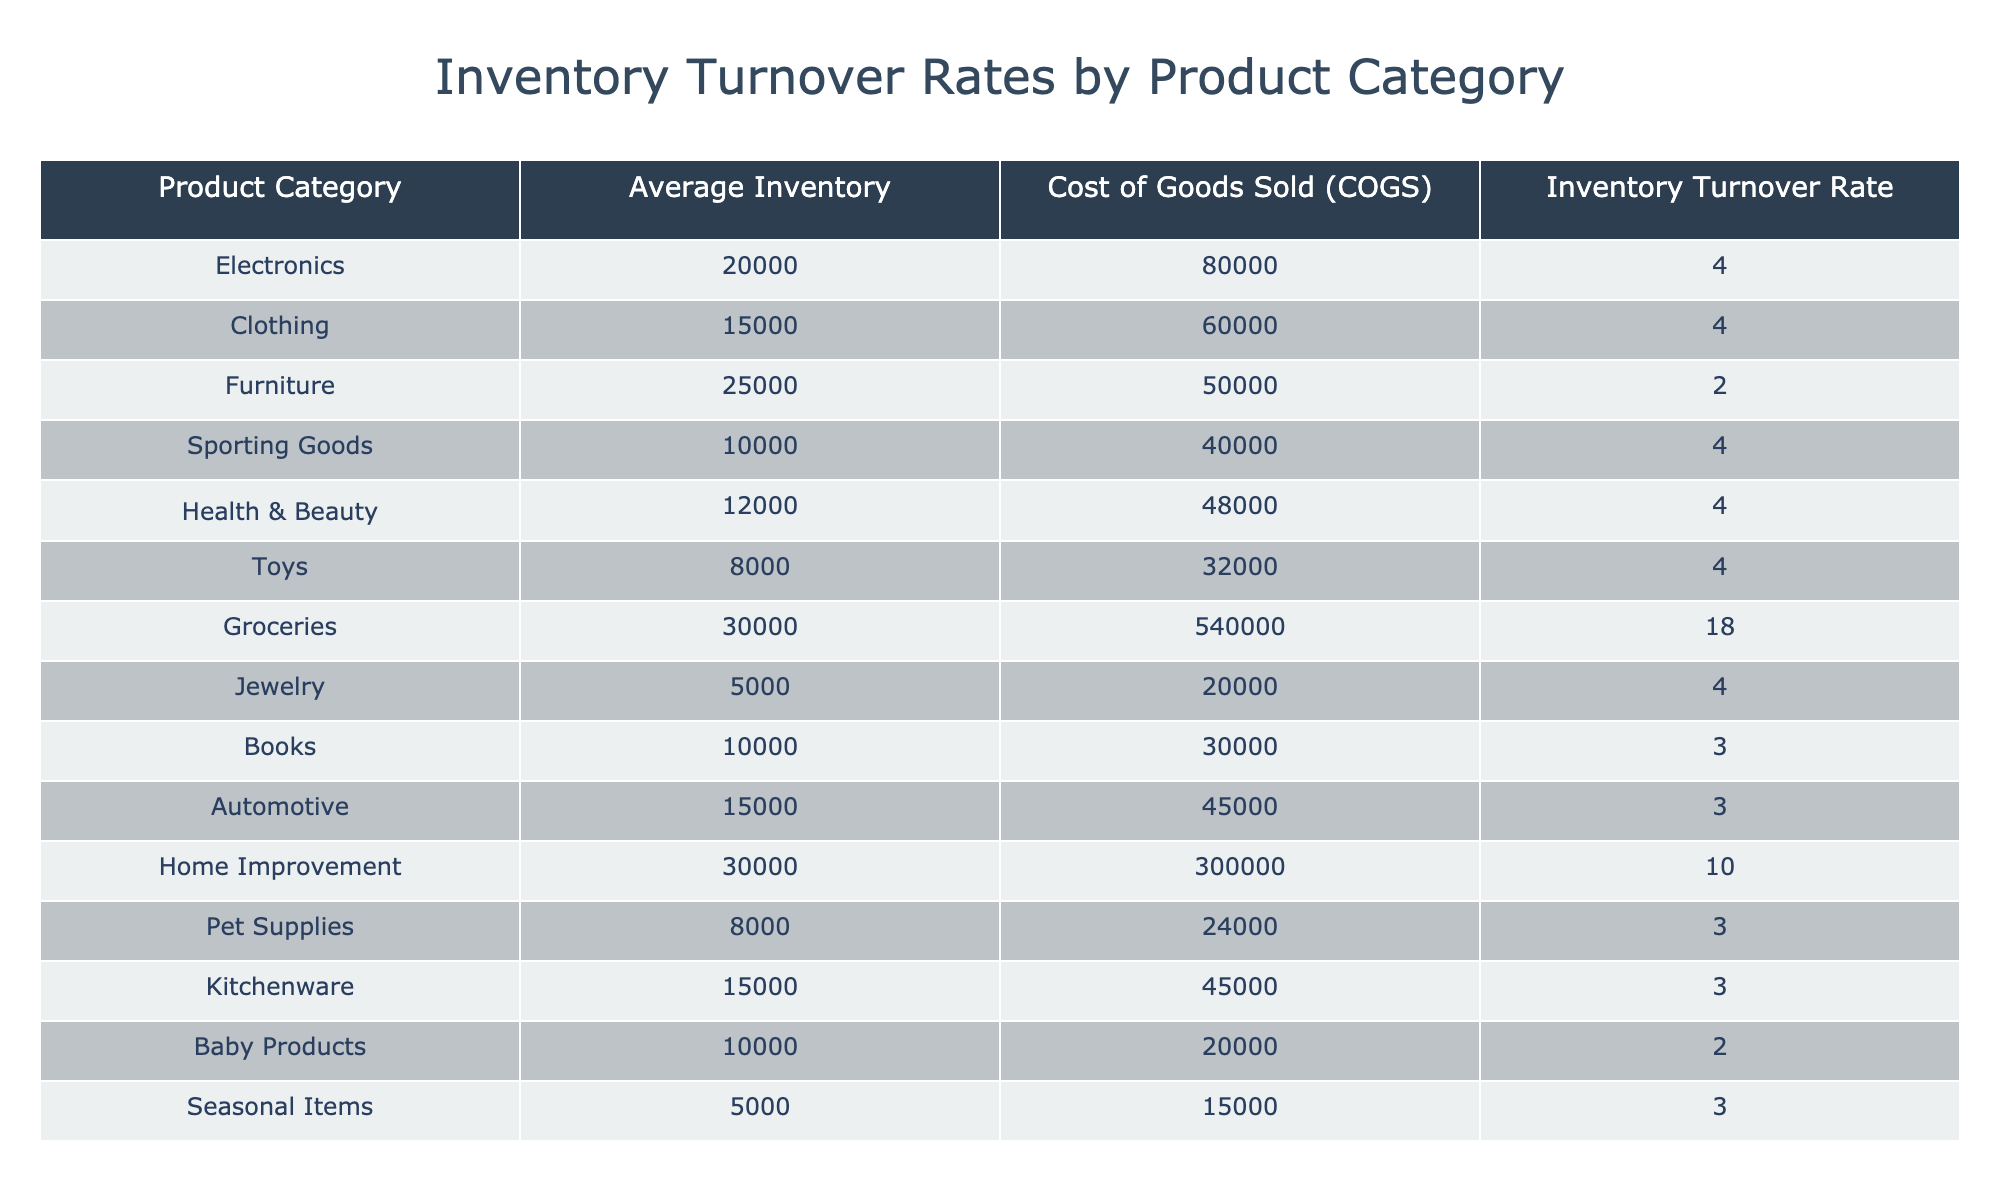What is the Inventory Turnover Rate for Groceries? The table explicitly lists the Inventory Turnover Rate for Groceries as 18.0.
Answer: 18.0 Which product category has the highest average inventory? By comparing the Average Inventory values, Groceries has the highest average inventory at 30,000.
Answer: Groceries How many product categories have an Inventory Turnover Rate of 4.0? The categories listed with an Inventory Turnover Rate of 4.0 are Electronics, Clothing, Sporting Goods, Health & Beauty, Toys, and Jewelry, totaling six categories.
Answer: 6 What is the average Inventory Turnover Rate for product categories with an average inventory of 15,000 or less? The relevant product categories are Toys (4.0), Jewelry (4.0), and Pet Supplies (3.0). Their average Inventory Turnover Rate is (4.0 + 4.0 + 3.0) / 3 = 3.67.
Answer: 3.67 Is the Inventory Turnover Rate for Furniture greater than that for Baby Products? The Inventory Turnover Rate for Furniture is 2.0, and for Baby Products, it is also 2.0. Since both are equal, the statement is false.
Answer: No How does the Inventory Turnover Rate for Home Improvement compare to that of Sporting Goods? Home Improvement has an Inventory Turnover Rate of 10.0 while Sporting Goods has 4.0. Since 10.0 > 4.0, Home Improvement has a higher rate.
Answer: Home Improvement is higher What is the combined Inventory Turnover Rate for all product categories with rates of 3.0 or lower? The categories with 3.0 or lower are Books (3.0), Automotive (3.0), Baby Products (2.0), and Pet Supplies (3.0). Their combined Inventory Turnover Rate is 3.0 + 3.0 + 2.0 + 3.0 = 11.0.
Answer: 11.0 Which category has the lowest Inventory Turnover Rate? From the table, Furniture has the lowest Inventory Turnover Rate of 2.0.
Answer: Furniture How many product categories have Inventory Turnover Rates above 4.0? The only category exceeding 4.0 is Groceries with an Inventory Turnover Rate of 18.0. Hence, there is one such category.
Answer: 1 